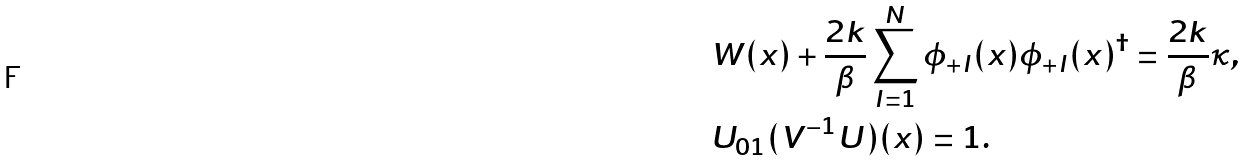<formula> <loc_0><loc_0><loc_500><loc_500>& W ( x ) + \frac { 2 k } { \beta } \sum _ { I = 1 } ^ { N } \phi _ { + I } ( x ) \phi _ { + I } ( x ) ^ { \dagger } = \frac { 2 k } { \beta } \kappa , \\ & U _ { 0 1 } ( V ^ { - 1 } U ) ( x ) = 1 .</formula> 